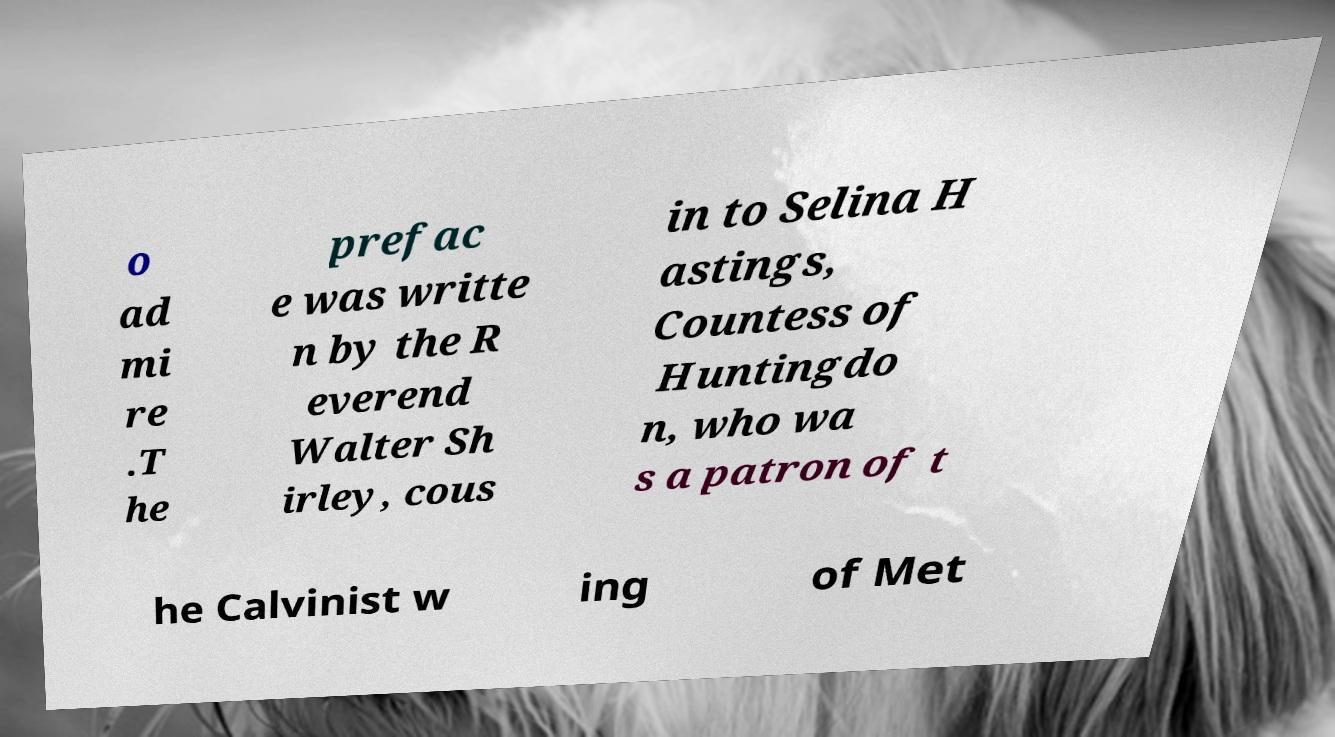For documentation purposes, I need the text within this image transcribed. Could you provide that? o ad mi re .T he prefac e was writte n by the R everend Walter Sh irley, cous in to Selina H astings, Countess of Huntingdo n, who wa s a patron of t he Calvinist w ing of Met 